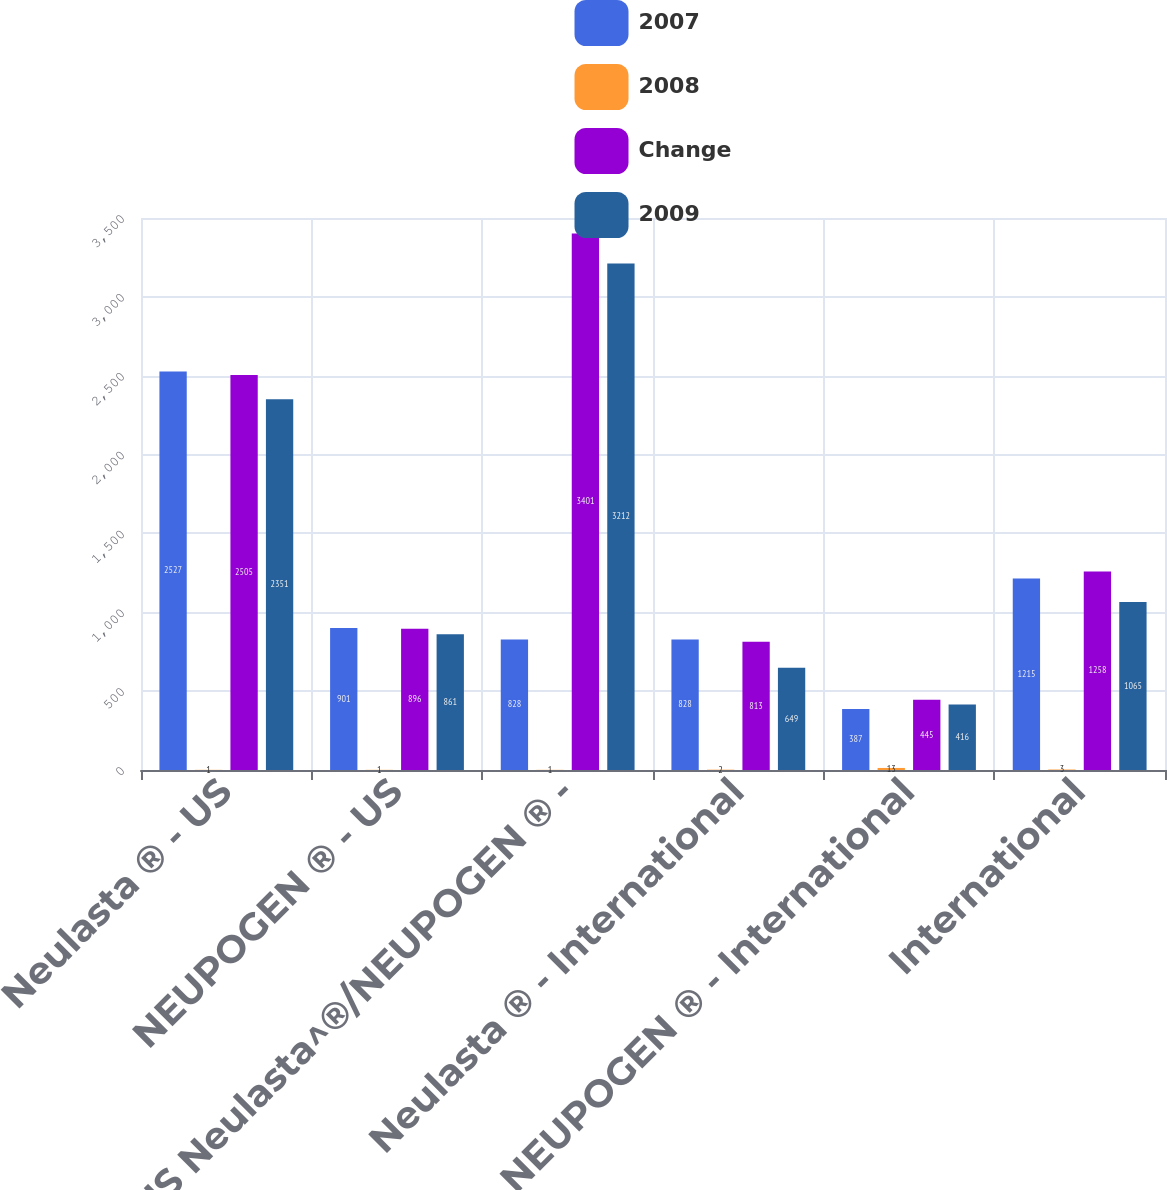Convert chart to OTSL. <chart><loc_0><loc_0><loc_500><loc_500><stacked_bar_chart><ecel><fcel>Neulasta ® - US<fcel>NEUPOGEN ® - US<fcel>US Neulasta^®/NEUPOGEN ® -<fcel>Neulasta ® - International<fcel>NEUPOGEN ® - International<fcel>International<nl><fcel>2007<fcel>2527<fcel>901<fcel>828<fcel>828<fcel>387<fcel>1215<nl><fcel>2008<fcel>1<fcel>1<fcel>1<fcel>2<fcel>13<fcel>3<nl><fcel>Change<fcel>2505<fcel>896<fcel>3401<fcel>813<fcel>445<fcel>1258<nl><fcel>2009<fcel>2351<fcel>861<fcel>3212<fcel>649<fcel>416<fcel>1065<nl></chart> 